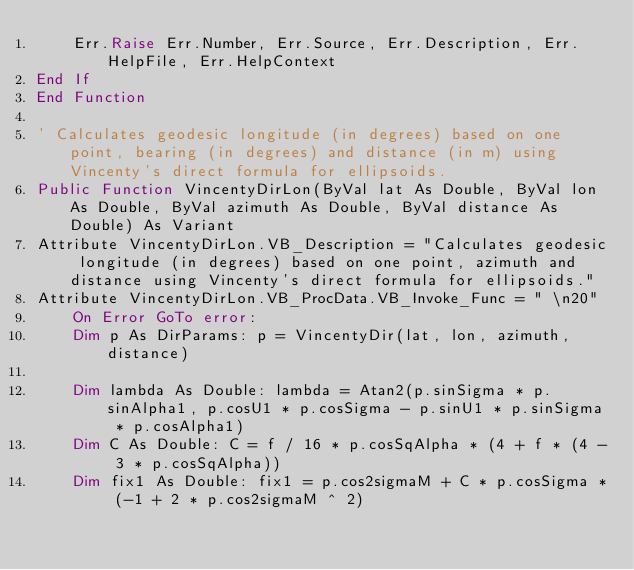Convert code to text. <code><loc_0><loc_0><loc_500><loc_500><_VisualBasic_>    Err.Raise Err.Number, Err.Source, Err.Description, Err.HelpFile, Err.HelpContext
End If
End Function

' Calculates geodesic longitude (in degrees) based on one point, bearing (in degrees) and distance (in m) using Vincenty's direct formula for ellipsoids.
Public Function VincentyDirLon(ByVal lat As Double, ByVal lon As Double, ByVal azimuth As Double, ByVal distance As Double) As Variant
Attribute VincentyDirLon.VB_Description = "Calculates geodesic longitude (in degrees) based on one point, azimuth and distance using Vincenty's direct formula for ellipsoids."
Attribute VincentyDirLon.VB_ProcData.VB_Invoke_Func = " \n20"
    On Error GoTo error:
    Dim p As DirParams: p = VincentyDir(lat, lon, azimuth, distance)
    
    Dim lambda As Double: lambda = Atan2(p.sinSigma * p.sinAlpha1, p.cosU1 * p.cosSigma - p.sinU1 * p.sinSigma * p.cosAlpha1)
    Dim C As Double: C = f / 16 * p.cosSqAlpha * (4 + f * (4 - 3 * p.cosSqAlpha))
    Dim fix1 As Double: fix1 = p.cos2sigmaM + C * p.cosSigma * (-1 + 2 * p.cos2sigmaM ^ 2)</code> 